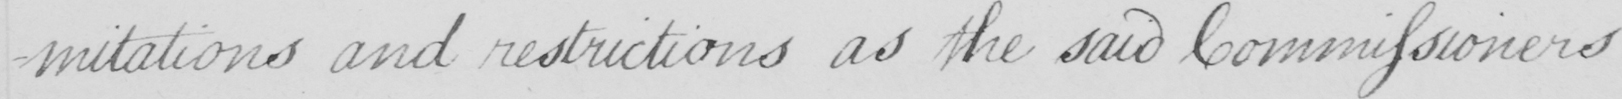Can you tell me what this handwritten text says? -mitations and restrictions as the said Commissioners 